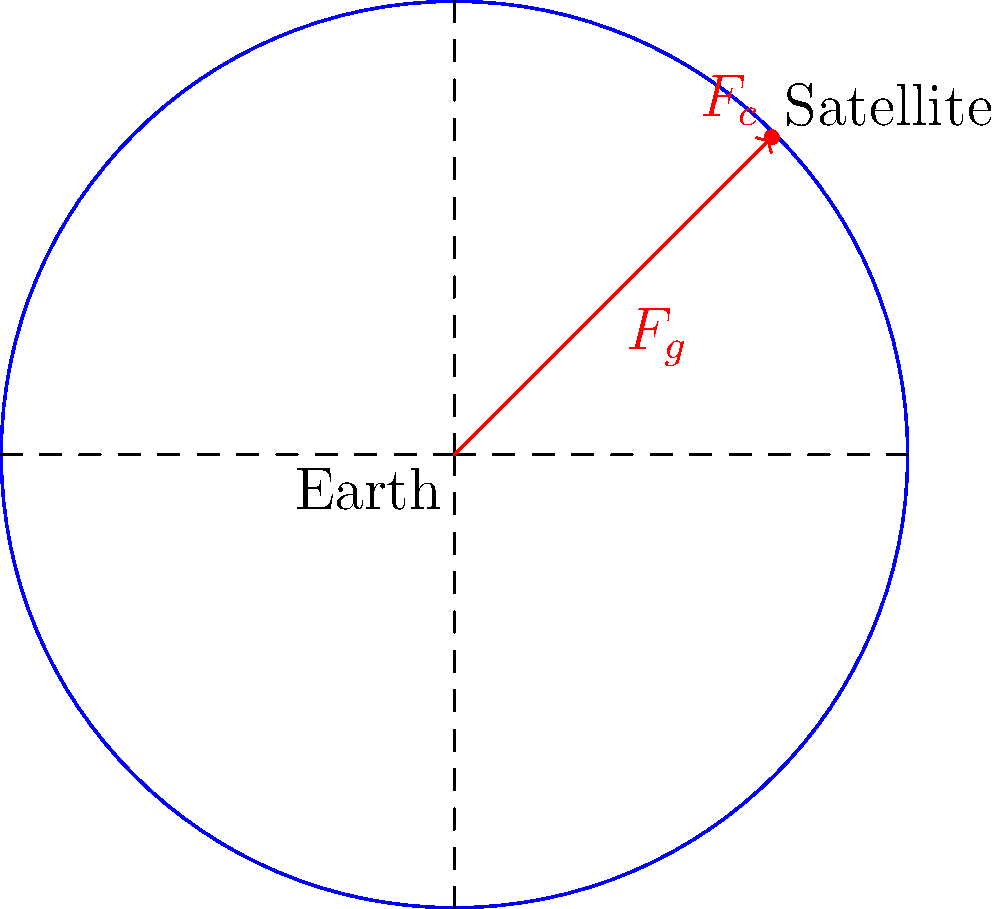A satellite orbits Earth in a circular path as shown in the diagram. Consider the forces acting on the satellite at the position indicated. Which of the following statements is true about the magnitudes of the gravitational force ($F_g$) and the centripetal force ($F_c$) acting on the satellite?

A) $F_g > F_c$
B) $F_g < F_c$
C) $F_g = F_c$
D) The relationship between $F_g$ and $F_c$ cannot be determined from the information given Let's approach this step-by-step:

1) For a satellite to maintain a stable circular orbit, the net force acting on it must be directed towards the center of the orbit (Earth's center in this case).

2) There are two main forces acting on the satellite:
   a) The gravitational force ($F_g$), which pulls the satellite towards Earth.
   b) The centripetal force ($F_c$), which is the net force required to keep the satellite moving in a circular path.

3) For the orbit to be stable, these forces must be in balance. If they weren't, the satellite would either spiral inward (if $F_g > F_c$) or spiral outward (if $F_g < F_c$).

4) In fact, for a circular orbit, the gravitational force provides the centripetal force. This means that:

   $$F_g = F_c = \frac{GMm}{r^2} = \frac{mv^2}{r}$$

   Where $G$ is the gravitational constant, $M$ is the mass of Earth, $m$ is the mass of the satellite, $r$ is the orbital radius, and $v$ is the orbital velocity.

5) This equality is what allows the satellite to maintain its circular orbit at a constant altitude.

Therefore, the correct statement is that the magnitudes of the gravitational force and the centripetal force are equal for a satellite in a stable circular orbit.
Answer: C) $F_g = F_c$ 